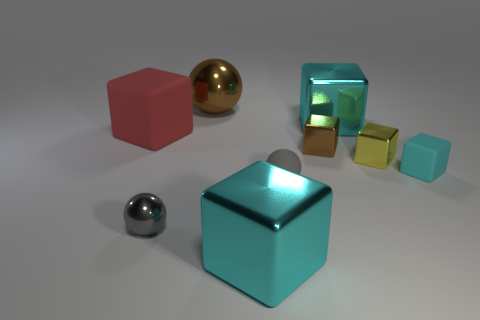How many cyan blocks must be subtracted to get 1 cyan blocks? 2 Subtract all big brown metal spheres. How many spheres are left? 2 Subtract all yellow cubes. How many gray spheres are left? 2 Add 1 large shiny objects. How many objects exist? 10 Subtract all cyan blocks. How many blocks are left? 3 Subtract 3 blocks. How many blocks are left? 3 Add 5 yellow shiny things. How many yellow shiny things are left? 6 Add 6 tiny cyan metallic things. How many tiny cyan metallic things exist? 6 Subtract 0 red spheres. How many objects are left? 9 Subtract all cubes. How many objects are left? 3 